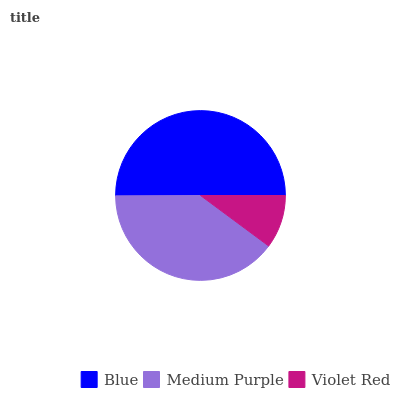Is Violet Red the minimum?
Answer yes or no. Yes. Is Blue the maximum?
Answer yes or no. Yes. Is Medium Purple the minimum?
Answer yes or no. No. Is Medium Purple the maximum?
Answer yes or no. No. Is Blue greater than Medium Purple?
Answer yes or no. Yes. Is Medium Purple less than Blue?
Answer yes or no. Yes. Is Medium Purple greater than Blue?
Answer yes or no. No. Is Blue less than Medium Purple?
Answer yes or no. No. Is Medium Purple the high median?
Answer yes or no. Yes. Is Medium Purple the low median?
Answer yes or no. Yes. Is Violet Red the high median?
Answer yes or no. No. Is Violet Red the low median?
Answer yes or no. No. 